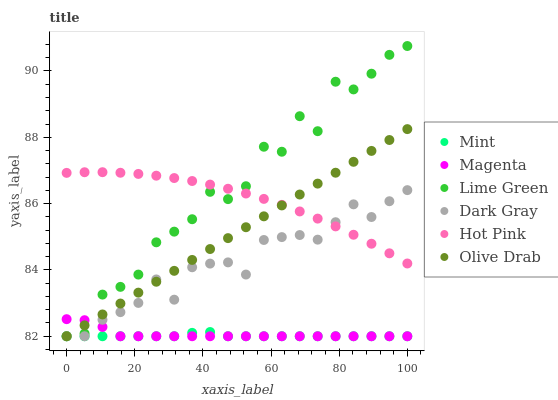Does Mint have the minimum area under the curve?
Answer yes or no. Yes. Does Lime Green have the maximum area under the curve?
Answer yes or no. Yes. Does Hot Pink have the minimum area under the curve?
Answer yes or no. No. Does Hot Pink have the maximum area under the curve?
Answer yes or no. No. Is Olive Drab the smoothest?
Answer yes or no. Yes. Is Lime Green the roughest?
Answer yes or no. Yes. Is Hot Pink the smoothest?
Answer yes or no. No. Is Hot Pink the roughest?
Answer yes or no. No. Does Mint have the lowest value?
Answer yes or no. Yes. Does Hot Pink have the lowest value?
Answer yes or no. No. Does Lime Green have the highest value?
Answer yes or no. Yes. Does Hot Pink have the highest value?
Answer yes or no. No. Is Mint less than Hot Pink?
Answer yes or no. Yes. Is Hot Pink greater than Mint?
Answer yes or no. Yes. Does Magenta intersect Dark Gray?
Answer yes or no. Yes. Is Magenta less than Dark Gray?
Answer yes or no. No. Is Magenta greater than Dark Gray?
Answer yes or no. No. Does Mint intersect Hot Pink?
Answer yes or no. No. 